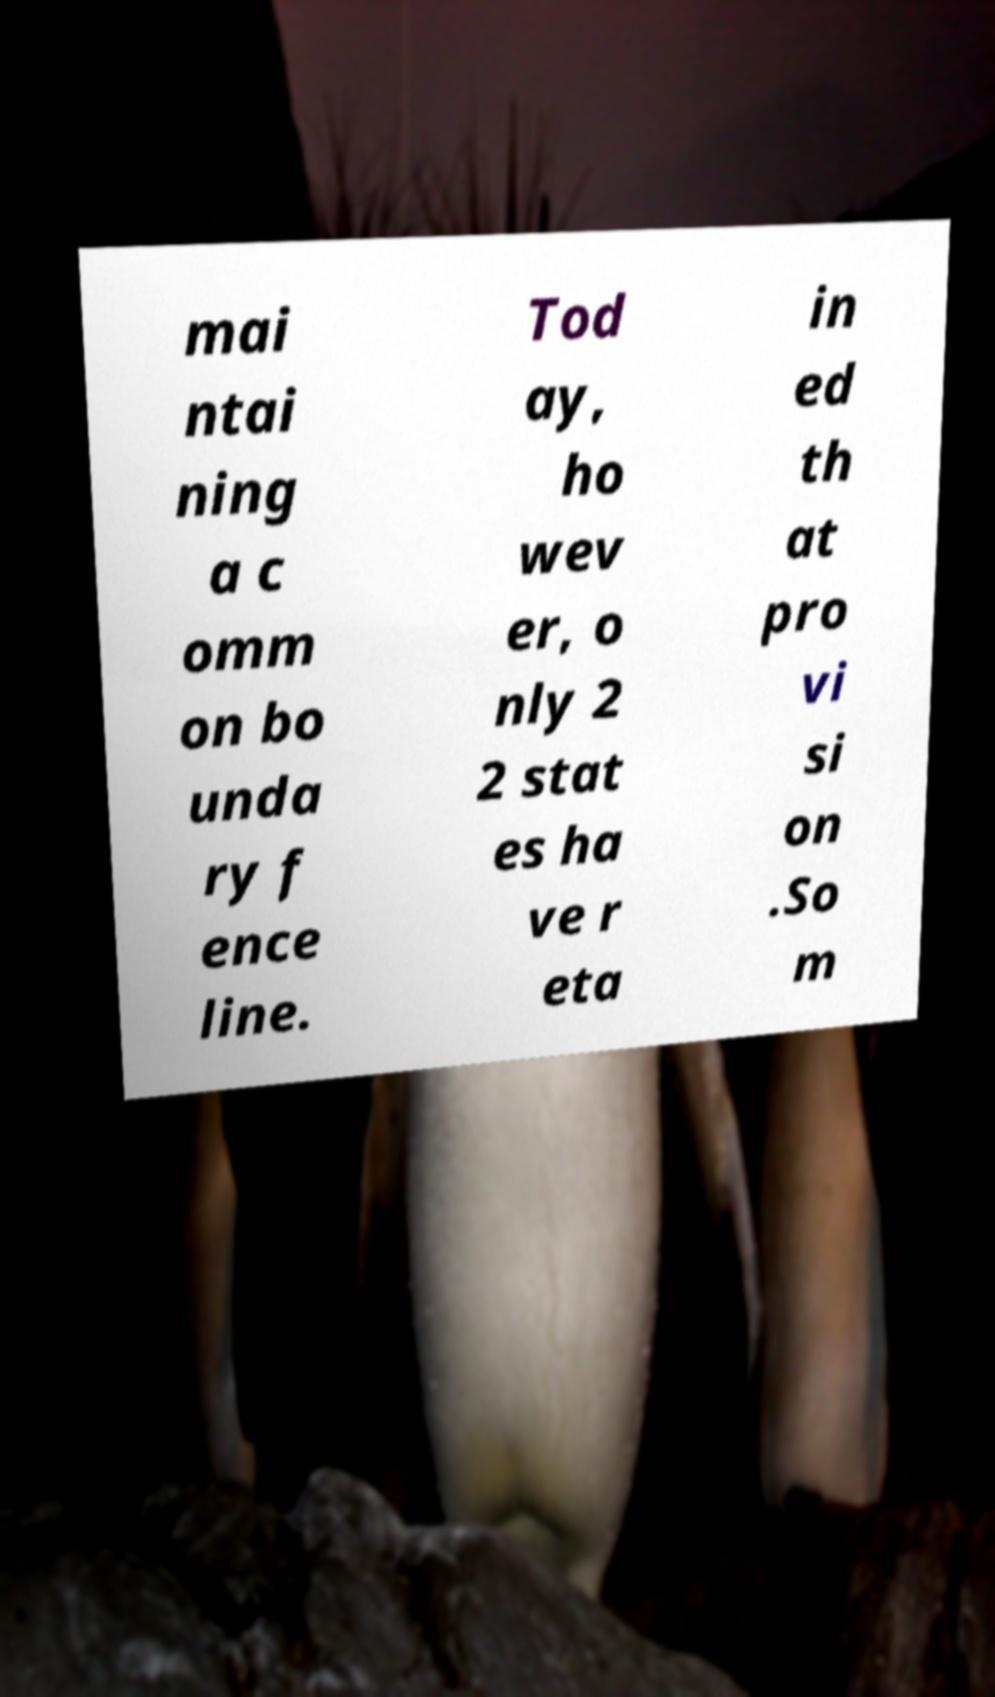What messages or text are displayed in this image? I need them in a readable, typed format. mai ntai ning a c omm on bo unda ry f ence line. Tod ay, ho wev er, o nly 2 2 stat es ha ve r eta in ed th at pro vi si on .So m 